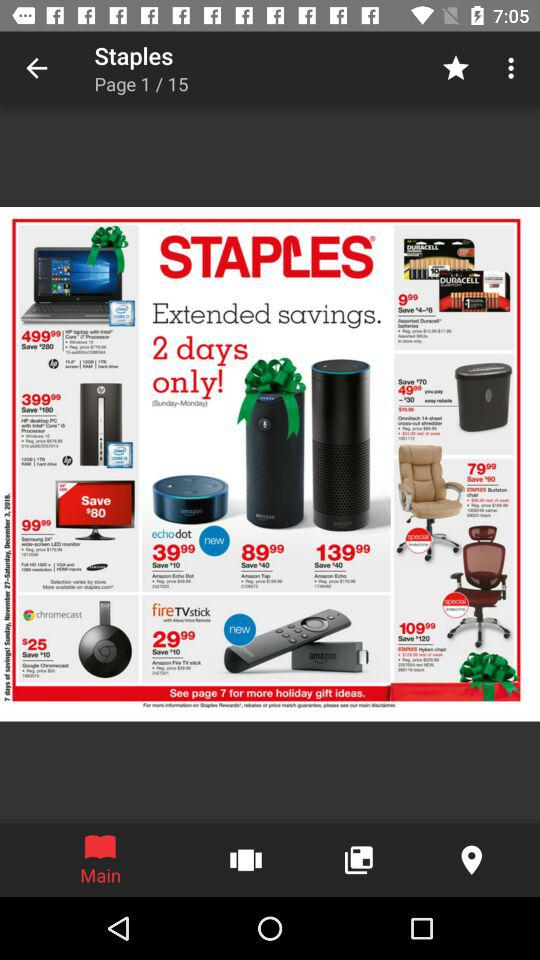What is the app name?
When the provided information is insufficient, respond with <no answer>. <no answer> 